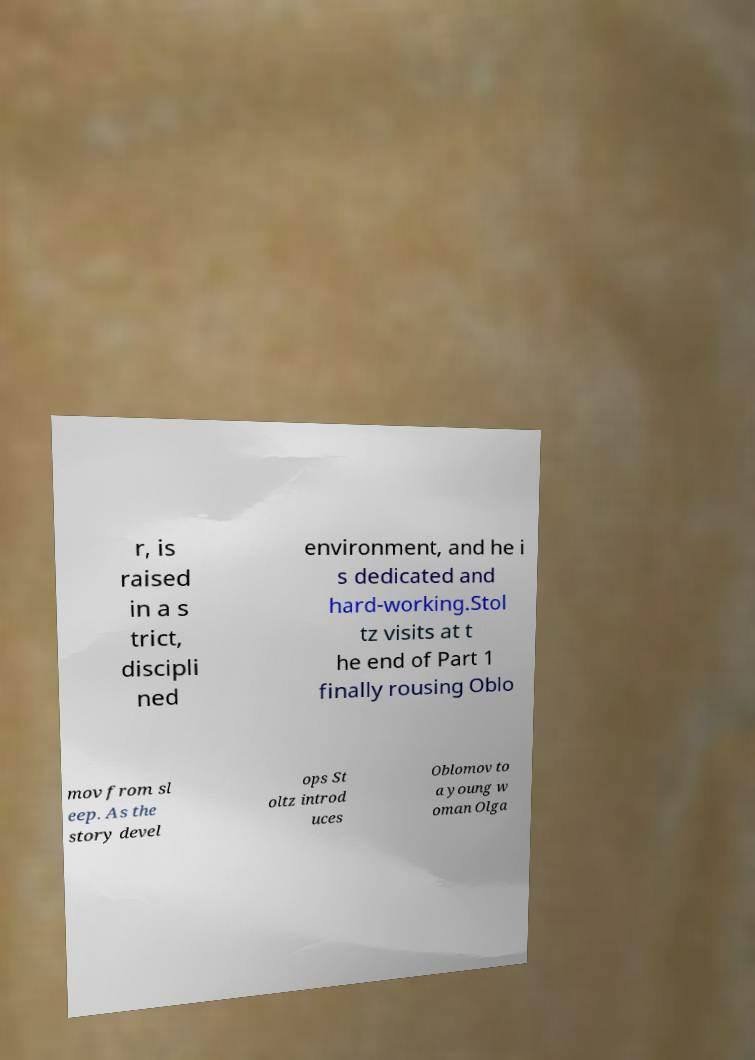I need the written content from this picture converted into text. Can you do that? r, is raised in a s trict, discipli ned environment, and he i s dedicated and hard-working.Stol tz visits at t he end of Part 1 finally rousing Oblo mov from sl eep. As the story devel ops St oltz introd uces Oblomov to a young w oman Olga 